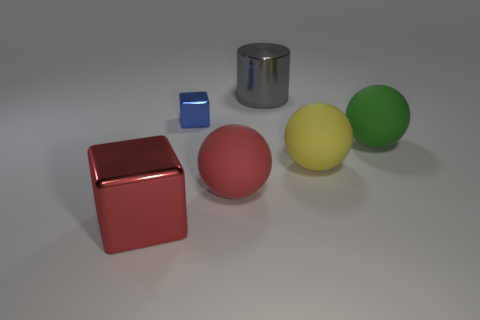What number of other things have the same shape as the gray metallic thing?
Provide a short and direct response. 0. There is a blue cube that is made of the same material as the large red cube; what is its size?
Provide a succinct answer. Small. Is the number of big metal things greater than the number of big spheres?
Provide a succinct answer. No. What is the color of the cube that is to the right of the large red shiny object?
Make the answer very short. Blue. There is a object that is on the right side of the large block and to the left of the big red matte ball; how big is it?
Your answer should be very brief. Small. What number of other yellow matte balls are the same size as the yellow rubber sphere?
Your response must be concise. 0. What material is the yellow thing that is the same shape as the green object?
Provide a succinct answer. Rubber. Is the blue object the same shape as the red metal object?
Provide a short and direct response. Yes. There is a large red matte ball; what number of big gray metallic things are in front of it?
Provide a short and direct response. 0. There is a large red thing that is left of the big ball that is to the left of the gray metallic thing; what is its shape?
Provide a succinct answer. Cube. 